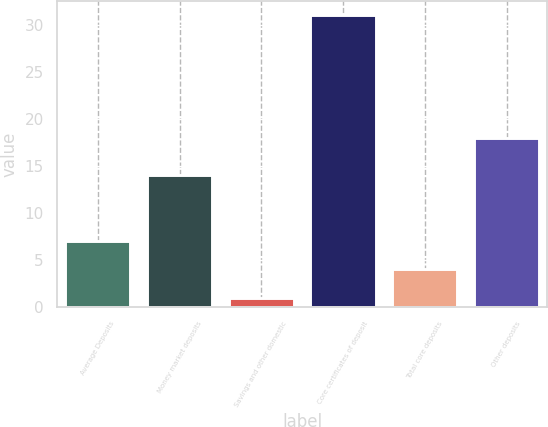Convert chart to OTSL. <chart><loc_0><loc_0><loc_500><loc_500><bar_chart><fcel>Average Deposits<fcel>Money market deposits<fcel>Savings and other domestic<fcel>Core certificates of deposit<fcel>Total core deposits<fcel>Other deposits<nl><fcel>7<fcel>14<fcel>1<fcel>31<fcel>4<fcel>18<nl></chart> 